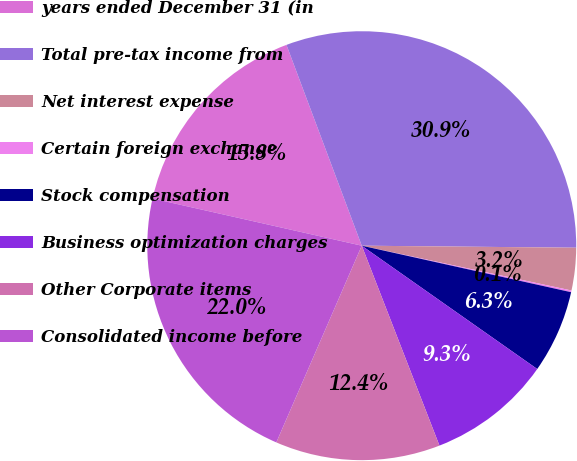Convert chart to OTSL. <chart><loc_0><loc_0><loc_500><loc_500><pie_chart><fcel>years ended December 31 (in<fcel>Total pre-tax income from<fcel>Net interest expense<fcel>Certain foreign exchange<fcel>Stock compensation<fcel>Business optimization charges<fcel>Other Corporate items<fcel>Consolidated income before<nl><fcel>15.76%<fcel>30.86%<fcel>3.2%<fcel>0.13%<fcel>6.27%<fcel>9.35%<fcel>12.42%<fcel>22.01%<nl></chart> 